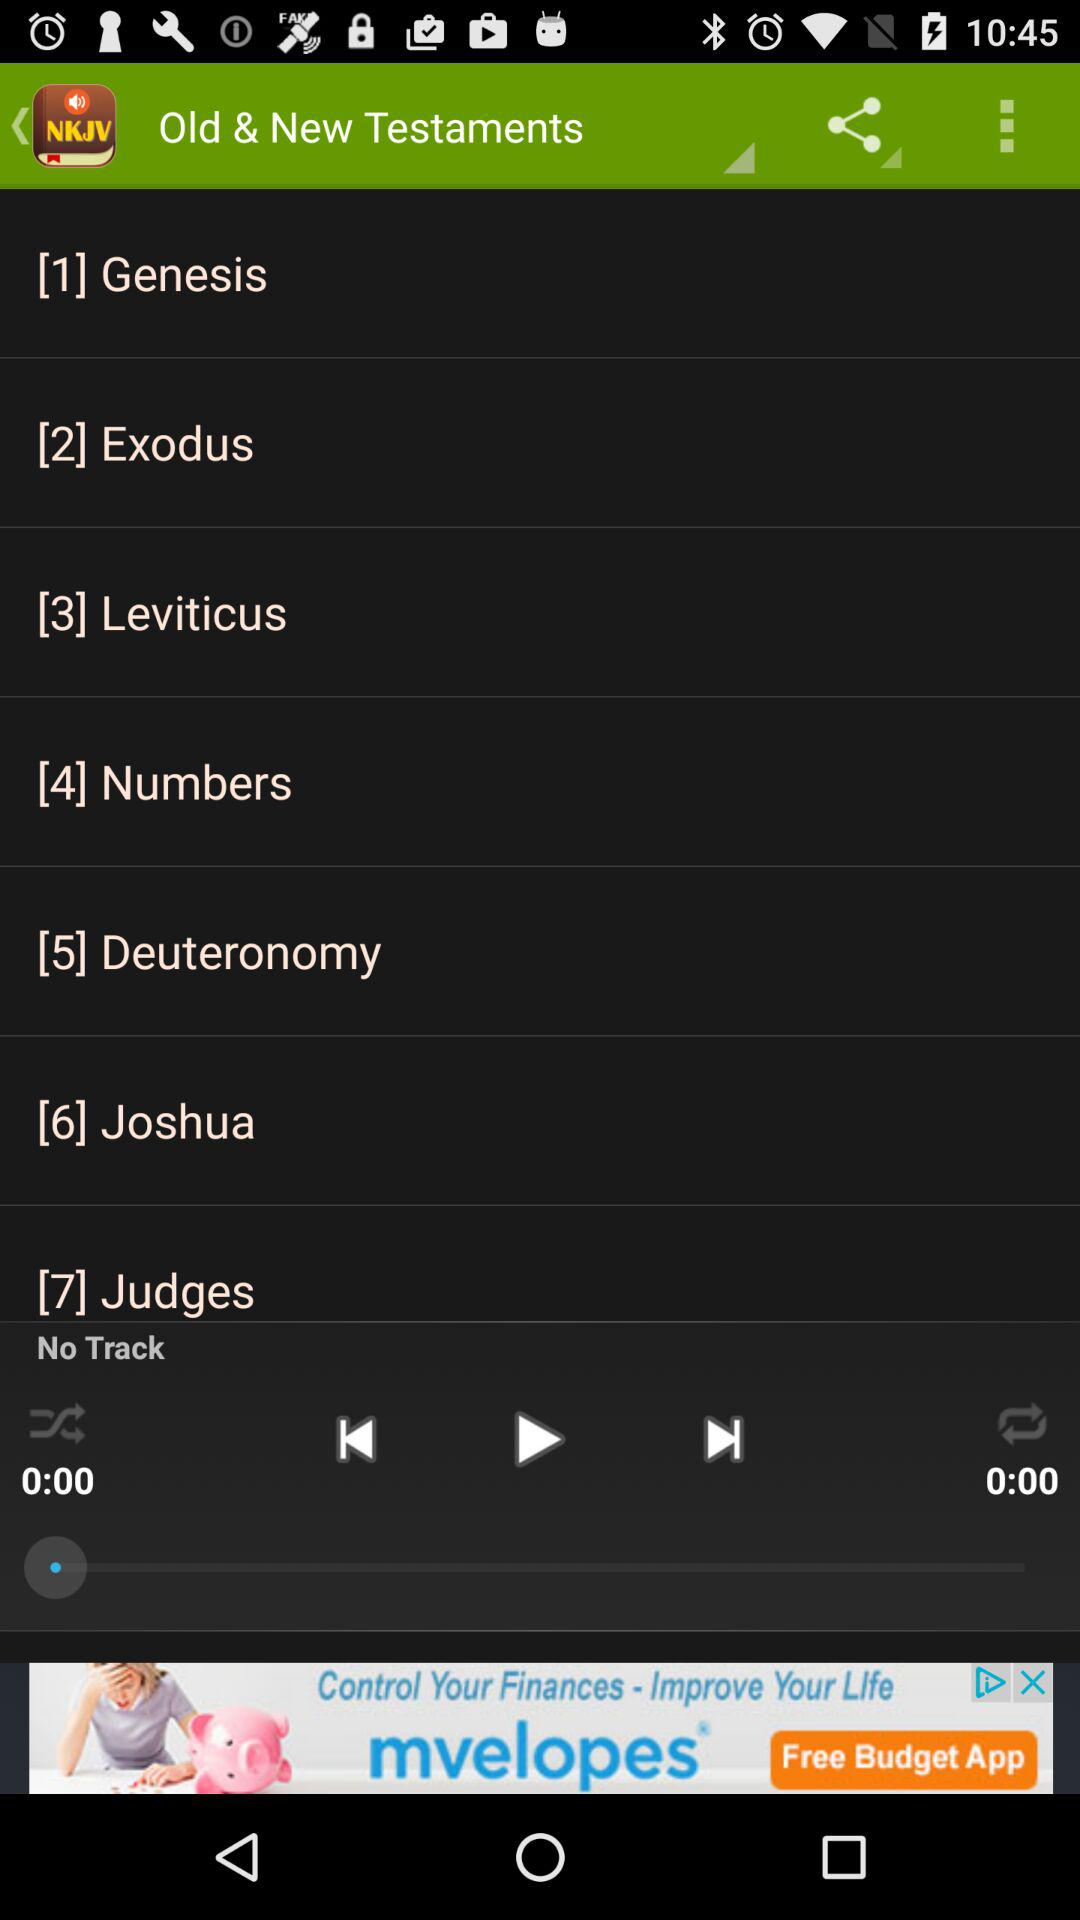Is there any track? There is no track. 